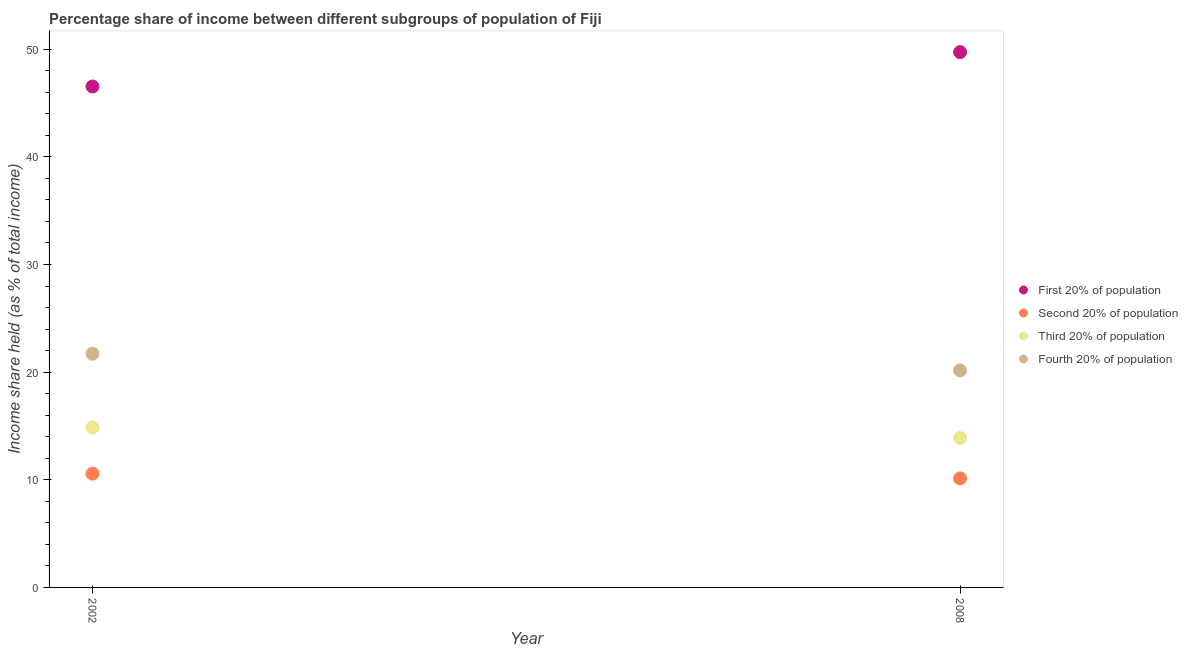How many different coloured dotlines are there?
Provide a succinct answer. 4. Is the number of dotlines equal to the number of legend labels?
Provide a short and direct response. Yes. What is the share of the income held by second 20% of the population in 2008?
Your answer should be very brief. 10.13. Across all years, what is the maximum share of the income held by second 20% of the population?
Make the answer very short. 10.57. Across all years, what is the minimum share of the income held by fourth 20% of the population?
Provide a succinct answer. 20.16. In which year was the share of the income held by first 20% of the population maximum?
Offer a terse response. 2008. What is the total share of the income held by fourth 20% of the population in the graph?
Ensure brevity in your answer.  41.87. What is the difference between the share of the income held by second 20% of the population in 2002 and that in 2008?
Provide a short and direct response. 0.44. What is the difference between the share of the income held by second 20% of the population in 2002 and the share of the income held by first 20% of the population in 2008?
Your answer should be compact. -39.16. What is the average share of the income held by second 20% of the population per year?
Ensure brevity in your answer.  10.35. In the year 2002, what is the difference between the share of the income held by first 20% of the population and share of the income held by second 20% of the population?
Provide a short and direct response. 35.97. In how many years, is the share of the income held by second 20% of the population greater than 20 %?
Provide a short and direct response. 0. What is the ratio of the share of the income held by fourth 20% of the population in 2002 to that in 2008?
Your response must be concise. 1.08. Is the share of the income held by first 20% of the population in 2002 less than that in 2008?
Your answer should be very brief. Yes. Is it the case that in every year, the sum of the share of the income held by first 20% of the population and share of the income held by second 20% of the population is greater than the share of the income held by third 20% of the population?
Your answer should be compact. Yes. Is the share of the income held by second 20% of the population strictly less than the share of the income held by third 20% of the population over the years?
Provide a succinct answer. Yes. How many dotlines are there?
Make the answer very short. 4. How many years are there in the graph?
Keep it short and to the point. 2. Are the values on the major ticks of Y-axis written in scientific E-notation?
Your answer should be compact. No. Does the graph contain grids?
Your answer should be compact. No. How many legend labels are there?
Offer a very short reply. 4. How are the legend labels stacked?
Your answer should be compact. Vertical. What is the title of the graph?
Give a very brief answer. Percentage share of income between different subgroups of population of Fiji. Does "Gender equality" appear as one of the legend labels in the graph?
Offer a terse response. No. What is the label or title of the Y-axis?
Make the answer very short. Income share held (as % of total income). What is the Income share held (as % of total income) of First 20% of population in 2002?
Your response must be concise. 46.54. What is the Income share held (as % of total income) in Second 20% of population in 2002?
Provide a succinct answer. 10.57. What is the Income share held (as % of total income) in Third 20% of population in 2002?
Keep it short and to the point. 14.86. What is the Income share held (as % of total income) of Fourth 20% of population in 2002?
Keep it short and to the point. 21.71. What is the Income share held (as % of total income) of First 20% of population in 2008?
Keep it short and to the point. 49.73. What is the Income share held (as % of total income) of Second 20% of population in 2008?
Make the answer very short. 10.13. What is the Income share held (as % of total income) of Third 20% of population in 2008?
Provide a succinct answer. 13.88. What is the Income share held (as % of total income) of Fourth 20% of population in 2008?
Provide a short and direct response. 20.16. Across all years, what is the maximum Income share held (as % of total income) in First 20% of population?
Your answer should be very brief. 49.73. Across all years, what is the maximum Income share held (as % of total income) in Second 20% of population?
Offer a terse response. 10.57. Across all years, what is the maximum Income share held (as % of total income) of Third 20% of population?
Provide a succinct answer. 14.86. Across all years, what is the maximum Income share held (as % of total income) in Fourth 20% of population?
Provide a short and direct response. 21.71. Across all years, what is the minimum Income share held (as % of total income) of First 20% of population?
Provide a succinct answer. 46.54. Across all years, what is the minimum Income share held (as % of total income) of Second 20% of population?
Your answer should be very brief. 10.13. Across all years, what is the minimum Income share held (as % of total income) in Third 20% of population?
Your answer should be compact. 13.88. Across all years, what is the minimum Income share held (as % of total income) in Fourth 20% of population?
Ensure brevity in your answer.  20.16. What is the total Income share held (as % of total income) of First 20% of population in the graph?
Give a very brief answer. 96.27. What is the total Income share held (as % of total income) of Second 20% of population in the graph?
Offer a terse response. 20.7. What is the total Income share held (as % of total income) of Third 20% of population in the graph?
Your answer should be very brief. 28.74. What is the total Income share held (as % of total income) of Fourth 20% of population in the graph?
Keep it short and to the point. 41.87. What is the difference between the Income share held (as % of total income) in First 20% of population in 2002 and that in 2008?
Your response must be concise. -3.19. What is the difference between the Income share held (as % of total income) in Second 20% of population in 2002 and that in 2008?
Offer a very short reply. 0.44. What is the difference between the Income share held (as % of total income) of Fourth 20% of population in 2002 and that in 2008?
Give a very brief answer. 1.55. What is the difference between the Income share held (as % of total income) in First 20% of population in 2002 and the Income share held (as % of total income) in Second 20% of population in 2008?
Your answer should be compact. 36.41. What is the difference between the Income share held (as % of total income) of First 20% of population in 2002 and the Income share held (as % of total income) of Third 20% of population in 2008?
Provide a succinct answer. 32.66. What is the difference between the Income share held (as % of total income) in First 20% of population in 2002 and the Income share held (as % of total income) in Fourth 20% of population in 2008?
Offer a very short reply. 26.38. What is the difference between the Income share held (as % of total income) in Second 20% of population in 2002 and the Income share held (as % of total income) in Third 20% of population in 2008?
Make the answer very short. -3.31. What is the difference between the Income share held (as % of total income) of Second 20% of population in 2002 and the Income share held (as % of total income) of Fourth 20% of population in 2008?
Make the answer very short. -9.59. What is the difference between the Income share held (as % of total income) in Third 20% of population in 2002 and the Income share held (as % of total income) in Fourth 20% of population in 2008?
Your answer should be very brief. -5.3. What is the average Income share held (as % of total income) in First 20% of population per year?
Your answer should be compact. 48.13. What is the average Income share held (as % of total income) of Second 20% of population per year?
Provide a short and direct response. 10.35. What is the average Income share held (as % of total income) in Third 20% of population per year?
Ensure brevity in your answer.  14.37. What is the average Income share held (as % of total income) in Fourth 20% of population per year?
Your answer should be very brief. 20.93. In the year 2002, what is the difference between the Income share held (as % of total income) of First 20% of population and Income share held (as % of total income) of Second 20% of population?
Give a very brief answer. 35.97. In the year 2002, what is the difference between the Income share held (as % of total income) of First 20% of population and Income share held (as % of total income) of Third 20% of population?
Keep it short and to the point. 31.68. In the year 2002, what is the difference between the Income share held (as % of total income) in First 20% of population and Income share held (as % of total income) in Fourth 20% of population?
Keep it short and to the point. 24.83. In the year 2002, what is the difference between the Income share held (as % of total income) of Second 20% of population and Income share held (as % of total income) of Third 20% of population?
Ensure brevity in your answer.  -4.29. In the year 2002, what is the difference between the Income share held (as % of total income) in Second 20% of population and Income share held (as % of total income) in Fourth 20% of population?
Provide a succinct answer. -11.14. In the year 2002, what is the difference between the Income share held (as % of total income) of Third 20% of population and Income share held (as % of total income) of Fourth 20% of population?
Your answer should be compact. -6.85. In the year 2008, what is the difference between the Income share held (as % of total income) of First 20% of population and Income share held (as % of total income) of Second 20% of population?
Ensure brevity in your answer.  39.6. In the year 2008, what is the difference between the Income share held (as % of total income) in First 20% of population and Income share held (as % of total income) in Third 20% of population?
Offer a terse response. 35.85. In the year 2008, what is the difference between the Income share held (as % of total income) in First 20% of population and Income share held (as % of total income) in Fourth 20% of population?
Provide a succinct answer. 29.57. In the year 2008, what is the difference between the Income share held (as % of total income) in Second 20% of population and Income share held (as % of total income) in Third 20% of population?
Provide a short and direct response. -3.75. In the year 2008, what is the difference between the Income share held (as % of total income) of Second 20% of population and Income share held (as % of total income) of Fourth 20% of population?
Your response must be concise. -10.03. In the year 2008, what is the difference between the Income share held (as % of total income) of Third 20% of population and Income share held (as % of total income) of Fourth 20% of population?
Provide a succinct answer. -6.28. What is the ratio of the Income share held (as % of total income) in First 20% of population in 2002 to that in 2008?
Ensure brevity in your answer.  0.94. What is the ratio of the Income share held (as % of total income) of Second 20% of population in 2002 to that in 2008?
Provide a short and direct response. 1.04. What is the ratio of the Income share held (as % of total income) in Third 20% of population in 2002 to that in 2008?
Your answer should be very brief. 1.07. What is the difference between the highest and the second highest Income share held (as % of total income) of First 20% of population?
Keep it short and to the point. 3.19. What is the difference between the highest and the second highest Income share held (as % of total income) of Second 20% of population?
Your answer should be compact. 0.44. What is the difference between the highest and the second highest Income share held (as % of total income) in Fourth 20% of population?
Offer a very short reply. 1.55. What is the difference between the highest and the lowest Income share held (as % of total income) in First 20% of population?
Offer a very short reply. 3.19. What is the difference between the highest and the lowest Income share held (as % of total income) in Second 20% of population?
Your answer should be very brief. 0.44. What is the difference between the highest and the lowest Income share held (as % of total income) in Fourth 20% of population?
Offer a terse response. 1.55. 